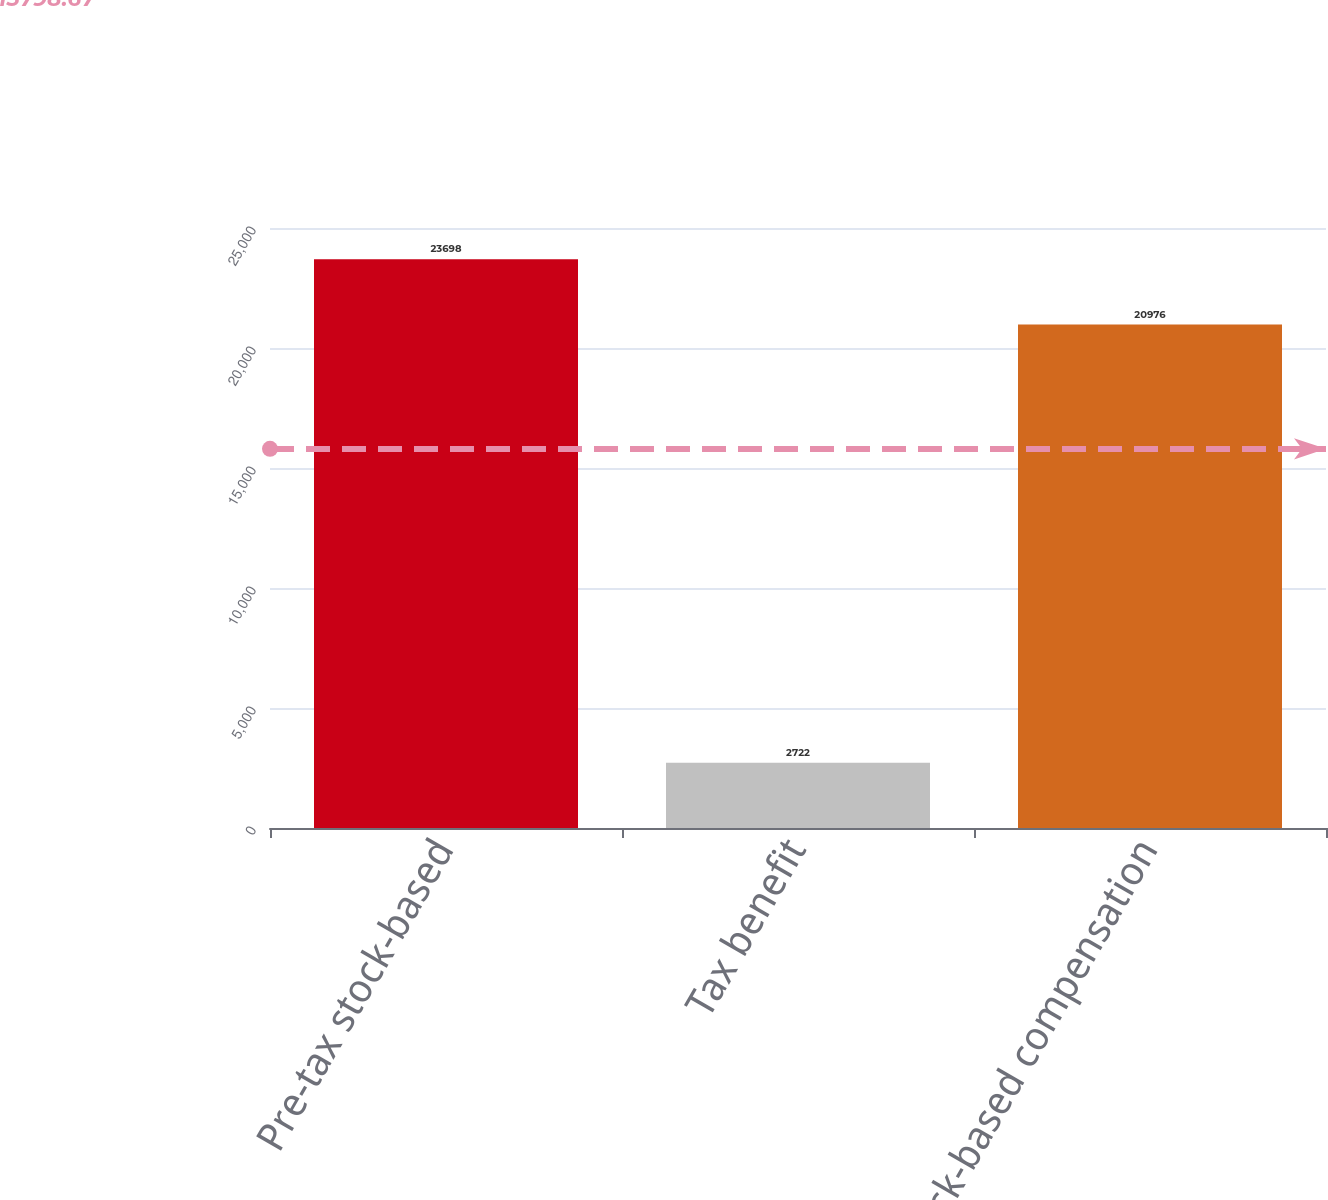<chart> <loc_0><loc_0><loc_500><loc_500><bar_chart><fcel>Pre-tax stock-based<fcel>Tax benefit<fcel>Total stock-based compensation<nl><fcel>23698<fcel>2722<fcel>20976<nl></chart> 